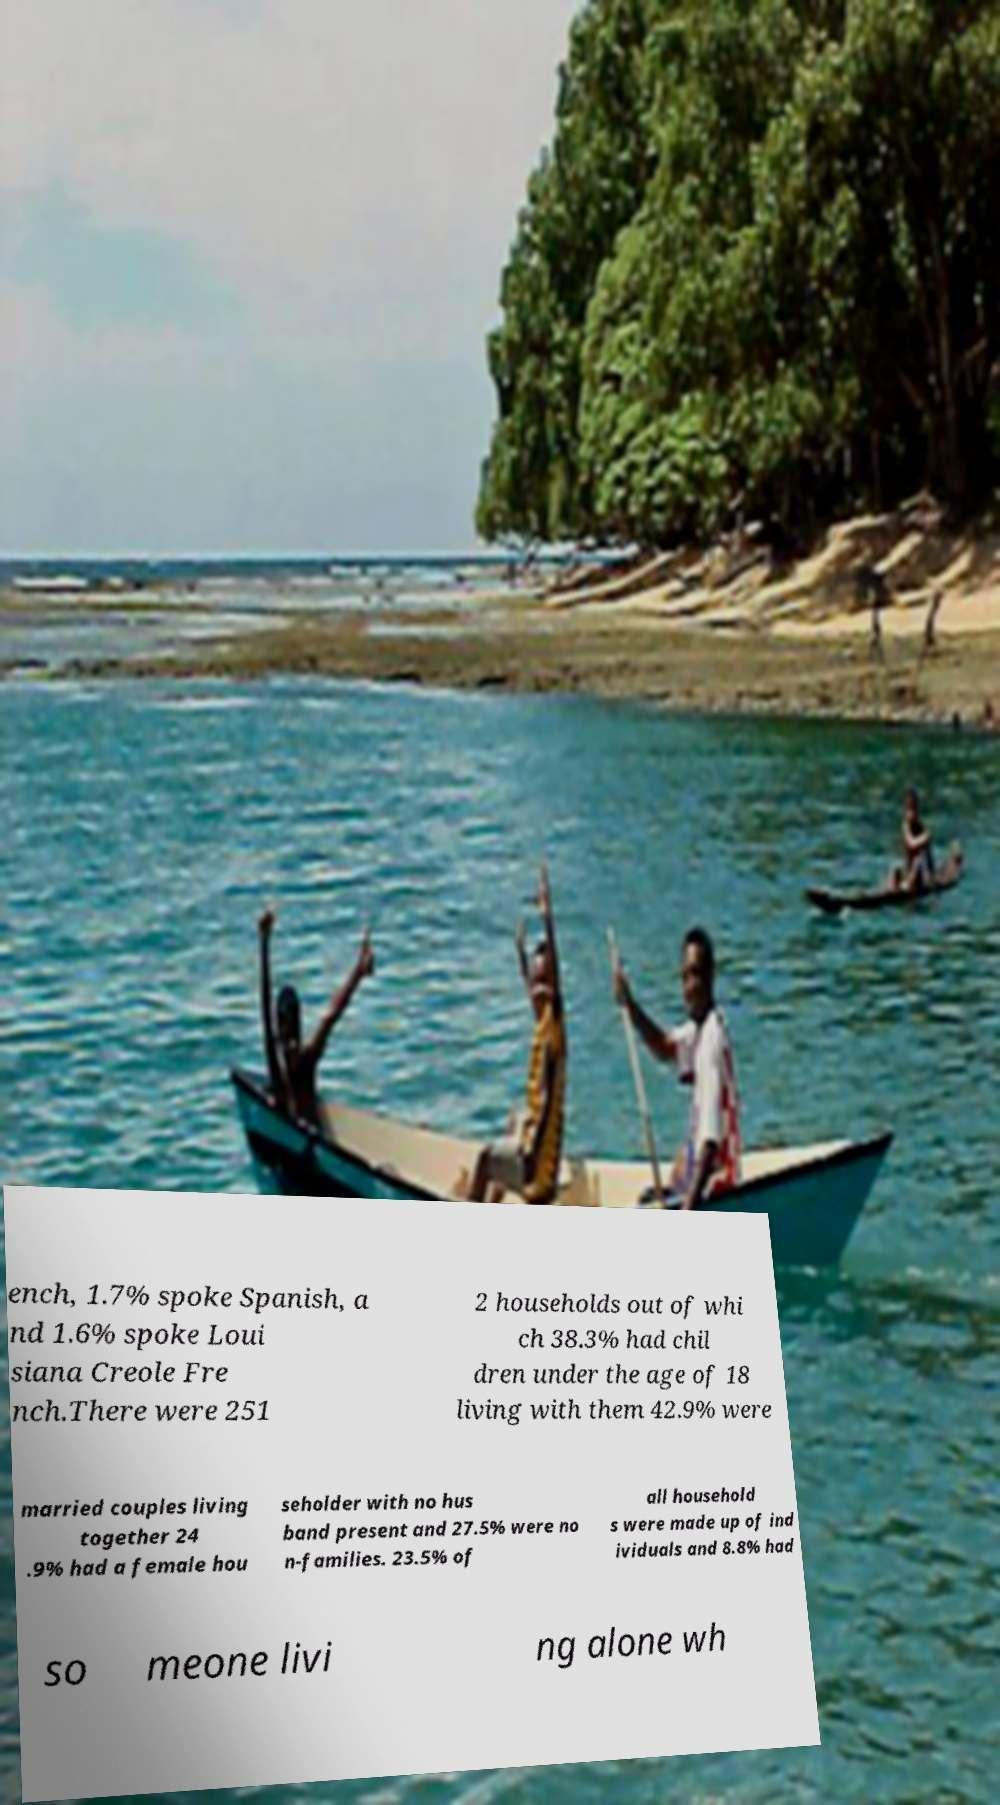Could you assist in decoding the text presented in this image and type it out clearly? ench, 1.7% spoke Spanish, a nd 1.6% spoke Loui siana Creole Fre nch.There were 251 2 households out of whi ch 38.3% had chil dren under the age of 18 living with them 42.9% were married couples living together 24 .9% had a female hou seholder with no hus band present and 27.5% were no n-families. 23.5% of all household s were made up of ind ividuals and 8.8% had so meone livi ng alone wh 